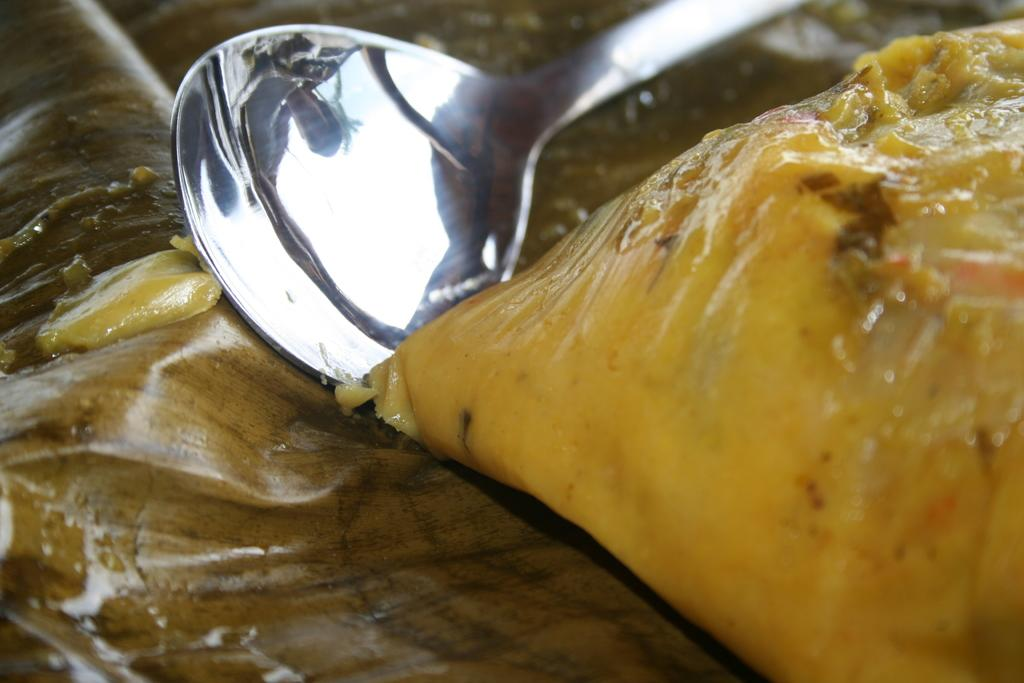What utensil is visible in the image? There is a spoon in the image. What is the spoon interacting with in the image? There is a food item in the image that the spoon is interacting with. Where are the spoon and food item located? The spoon and food item are on a surface in the image. What type of rod can be seen supporting the tent in the image? There is no rod or tent present in the image; it only features a spoon and a food item on a surface. 